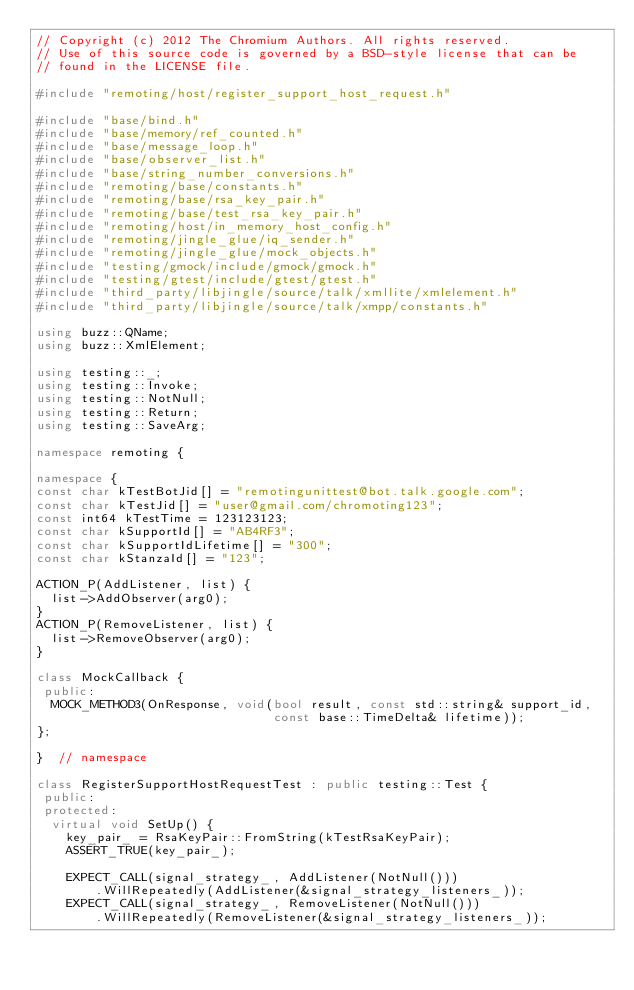Convert code to text. <code><loc_0><loc_0><loc_500><loc_500><_C++_>// Copyright (c) 2012 The Chromium Authors. All rights reserved.
// Use of this source code is governed by a BSD-style license that can be
// found in the LICENSE file.

#include "remoting/host/register_support_host_request.h"

#include "base/bind.h"
#include "base/memory/ref_counted.h"
#include "base/message_loop.h"
#include "base/observer_list.h"
#include "base/string_number_conversions.h"
#include "remoting/base/constants.h"
#include "remoting/base/rsa_key_pair.h"
#include "remoting/base/test_rsa_key_pair.h"
#include "remoting/host/in_memory_host_config.h"
#include "remoting/jingle_glue/iq_sender.h"
#include "remoting/jingle_glue/mock_objects.h"
#include "testing/gmock/include/gmock/gmock.h"
#include "testing/gtest/include/gtest/gtest.h"
#include "third_party/libjingle/source/talk/xmllite/xmlelement.h"
#include "third_party/libjingle/source/talk/xmpp/constants.h"

using buzz::QName;
using buzz::XmlElement;

using testing::_;
using testing::Invoke;
using testing::NotNull;
using testing::Return;
using testing::SaveArg;

namespace remoting {

namespace {
const char kTestBotJid[] = "remotingunittest@bot.talk.google.com";
const char kTestJid[] = "user@gmail.com/chromoting123";
const int64 kTestTime = 123123123;
const char kSupportId[] = "AB4RF3";
const char kSupportIdLifetime[] = "300";
const char kStanzaId[] = "123";

ACTION_P(AddListener, list) {
  list->AddObserver(arg0);
}
ACTION_P(RemoveListener, list) {
  list->RemoveObserver(arg0);
}

class MockCallback {
 public:
  MOCK_METHOD3(OnResponse, void(bool result, const std::string& support_id,
                                const base::TimeDelta& lifetime));
};

}  // namespace

class RegisterSupportHostRequestTest : public testing::Test {
 public:
 protected:
  virtual void SetUp() {
    key_pair_ = RsaKeyPair::FromString(kTestRsaKeyPair);
    ASSERT_TRUE(key_pair_);

    EXPECT_CALL(signal_strategy_, AddListener(NotNull()))
        .WillRepeatedly(AddListener(&signal_strategy_listeners_));
    EXPECT_CALL(signal_strategy_, RemoveListener(NotNull()))
        .WillRepeatedly(RemoveListener(&signal_strategy_listeners_));</code> 